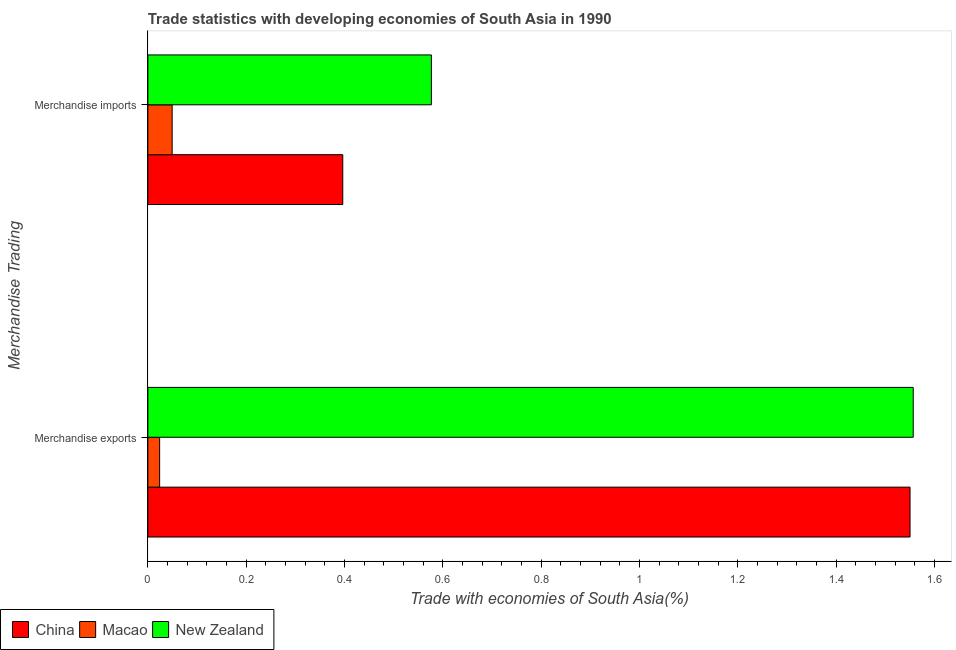Are the number of bars on each tick of the Y-axis equal?
Offer a very short reply. Yes. How many bars are there on the 2nd tick from the bottom?
Your answer should be very brief. 3. What is the merchandise exports in China?
Provide a short and direct response. 1.55. Across all countries, what is the maximum merchandise exports?
Your response must be concise. 1.56. Across all countries, what is the minimum merchandise exports?
Your answer should be very brief. 0.02. In which country was the merchandise exports maximum?
Keep it short and to the point. New Zealand. In which country was the merchandise exports minimum?
Provide a short and direct response. Macao. What is the total merchandise imports in the graph?
Your response must be concise. 1.02. What is the difference between the merchandise exports in Macao and that in China?
Your answer should be very brief. -1.53. What is the difference between the merchandise exports in New Zealand and the merchandise imports in Macao?
Keep it short and to the point. 1.51. What is the average merchandise exports per country?
Ensure brevity in your answer.  1.04. What is the difference between the merchandise exports and merchandise imports in New Zealand?
Your answer should be very brief. 0.98. In how many countries, is the merchandise imports greater than 1 %?
Make the answer very short. 0. What is the ratio of the merchandise imports in China to that in New Zealand?
Give a very brief answer. 0.69. What does the 2nd bar from the top in Merchandise exports represents?
Your response must be concise. Macao. What does the 3rd bar from the bottom in Merchandise exports represents?
Make the answer very short. New Zealand. How many bars are there?
Your response must be concise. 6. Are all the bars in the graph horizontal?
Your answer should be compact. Yes. What is the difference between two consecutive major ticks on the X-axis?
Your response must be concise. 0.2. Does the graph contain grids?
Provide a succinct answer. No. How many legend labels are there?
Keep it short and to the point. 3. What is the title of the graph?
Offer a very short reply. Trade statistics with developing economies of South Asia in 1990. What is the label or title of the X-axis?
Your answer should be very brief. Trade with economies of South Asia(%). What is the label or title of the Y-axis?
Offer a very short reply. Merchandise Trading. What is the Trade with economies of South Asia(%) in China in Merchandise exports?
Give a very brief answer. 1.55. What is the Trade with economies of South Asia(%) of Macao in Merchandise exports?
Keep it short and to the point. 0.02. What is the Trade with economies of South Asia(%) of New Zealand in Merchandise exports?
Give a very brief answer. 1.56. What is the Trade with economies of South Asia(%) of China in Merchandise imports?
Your answer should be very brief. 0.4. What is the Trade with economies of South Asia(%) in Macao in Merchandise imports?
Your answer should be compact. 0.05. What is the Trade with economies of South Asia(%) of New Zealand in Merchandise imports?
Offer a terse response. 0.58. Across all Merchandise Trading, what is the maximum Trade with economies of South Asia(%) of China?
Ensure brevity in your answer.  1.55. Across all Merchandise Trading, what is the maximum Trade with economies of South Asia(%) of Macao?
Provide a succinct answer. 0.05. Across all Merchandise Trading, what is the maximum Trade with economies of South Asia(%) of New Zealand?
Provide a short and direct response. 1.56. Across all Merchandise Trading, what is the minimum Trade with economies of South Asia(%) of China?
Offer a very short reply. 0.4. Across all Merchandise Trading, what is the minimum Trade with economies of South Asia(%) of Macao?
Give a very brief answer. 0.02. Across all Merchandise Trading, what is the minimum Trade with economies of South Asia(%) in New Zealand?
Keep it short and to the point. 0.58. What is the total Trade with economies of South Asia(%) in China in the graph?
Offer a very short reply. 1.95. What is the total Trade with economies of South Asia(%) of Macao in the graph?
Your response must be concise. 0.07. What is the total Trade with economies of South Asia(%) in New Zealand in the graph?
Your response must be concise. 2.13. What is the difference between the Trade with economies of South Asia(%) in China in Merchandise exports and that in Merchandise imports?
Provide a succinct answer. 1.15. What is the difference between the Trade with economies of South Asia(%) in Macao in Merchandise exports and that in Merchandise imports?
Make the answer very short. -0.03. What is the difference between the Trade with economies of South Asia(%) of New Zealand in Merchandise exports and that in Merchandise imports?
Offer a terse response. 0.98. What is the difference between the Trade with economies of South Asia(%) of China in Merchandise exports and the Trade with economies of South Asia(%) of Macao in Merchandise imports?
Keep it short and to the point. 1.5. What is the difference between the Trade with economies of South Asia(%) in China in Merchandise exports and the Trade with economies of South Asia(%) in New Zealand in Merchandise imports?
Provide a succinct answer. 0.97. What is the difference between the Trade with economies of South Asia(%) in Macao in Merchandise exports and the Trade with economies of South Asia(%) in New Zealand in Merchandise imports?
Provide a succinct answer. -0.55. What is the average Trade with economies of South Asia(%) in China per Merchandise Trading?
Give a very brief answer. 0.97. What is the average Trade with economies of South Asia(%) in Macao per Merchandise Trading?
Your response must be concise. 0.04. What is the average Trade with economies of South Asia(%) of New Zealand per Merchandise Trading?
Offer a terse response. 1.07. What is the difference between the Trade with economies of South Asia(%) of China and Trade with economies of South Asia(%) of Macao in Merchandise exports?
Your response must be concise. 1.53. What is the difference between the Trade with economies of South Asia(%) of China and Trade with economies of South Asia(%) of New Zealand in Merchandise exports?
Give a very brief answer. -0.01. What is the difference between the Trade with economies of South Asia(%) in Macao and Trade with economies of South Asia(%) in New Zealand in Merchandise exports?
Provide a succinct answer. -1.53. What is the difference between the Trade with economies of South Asia(%) in China and Trade with economies of South Asia(%) in Macao in Merchandise imports?
Your answer should be very brief. 0.35. What is the difference between the Trade with economies of South Asia(%) in China and Trade with economies of South Asia(%) in New Zealand in Merchandise imports?
Offer a terse response. -0.18. What is the difference between the Trade with economies of South Asia(%) of Macao and Trade with economies of South Asia(%) of New Zealand in Merchandise imports?
Provide a succinct answer. -0.53. What is the ratio of the Trade with economies of South Asia(%) of China in Merchandise exports to that in Merchandise imports?
Give a very brief answer. 3.91. What is the ratio of the Trade with economies of South Asia(%) in Macao in Merchandise exports to that in Merchandise imports?
Keep it short and to the point. 0.48. What is the ratio of the Trade with economies of South Asia(%) of New Zealand in Merchandise exports to that in Merchandise imports?
Your answer should be very brief. 2.7. What is the difference between the highest and the second highest Trade with economies of South Asia(%) in China?
Offer a very short reply. 1.15. What is the difference between the highest and the second highest Trade with economies of South Asia(%) in Macao?
Your response must be concise. 0.03. What is the difference between the highest and the second highest Trade with economies of South Asia(%) of New Zealand?
Offer a very short reply. 0.98. What is the difference between the highest and the lowest Trade with economies of South Asia(%) in China?
Provide a short and direct response. 1.15. What is the difference between the highest and the lowest Trade with economies of South Asia(%) in Macao?
Keep it short and to the point. 0.03. What is the difference between the highest and the lowest Trade with economies of South Asia(%) of New Zealand?
Make the answer very short. 0.98. 